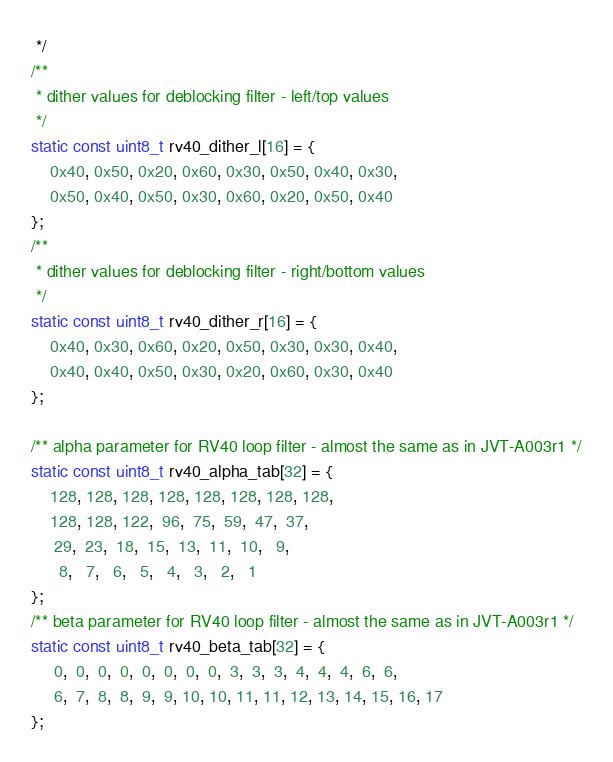Convert code to text. <code><loc_0><loc_0><loc_500><loc_500><_C_> */
/**
 * dither values for deblocking filter - left/top values
 */
static const uint8_t rv40_dither_l[16] = {
    0x40, 0x50, 0x20, 0x60, 0x30, 0x50, 0x40, 0x30,
    0x50, 0x40, 0x50, 0x30, 0x60, 0x20, 0x50, 0x40
};
/**
 * dither values for deblocking filter - right/bottom values
 */
static const uint8_t rv40_dither_r[16] = {
    0x40, 0x30, 0x60, 0x20, 0x50, 0x30, 0x30, 0x40,
    0x40, 0x40, 0x50, 0x30, 0x20, 0x60, 0x30, 0x40
};

/** alpha parameter for RV40 loop filter - almost the same as in JVT-A003r1 */
static const uint8_t rv40_alpha_tab[32] = {
    128, 128, 128, 128, 128, 128, 128, 128,
    128, 128, 122,  96,  75,  59,  47,  37,
     29,  23,  18,  15,  13,  11,  10,   9,
      8,   7,   6,   5,   4,   3,   2,   1
};
/** beta parameter for RV40 loop filter - almost the same as in JVT-A003r1 */
static const uint8_t rv40_beta_tab[32] = {
     0,  0,  0,  0,  0,  0,  0,  0,  3,  3,  3,  4,  4,  4,  6,  6,
     6,  7,  8,  8,  9,  9, 10, 10, 11, 11, 12, 13, 14, 15, 16, 17
};</code> 